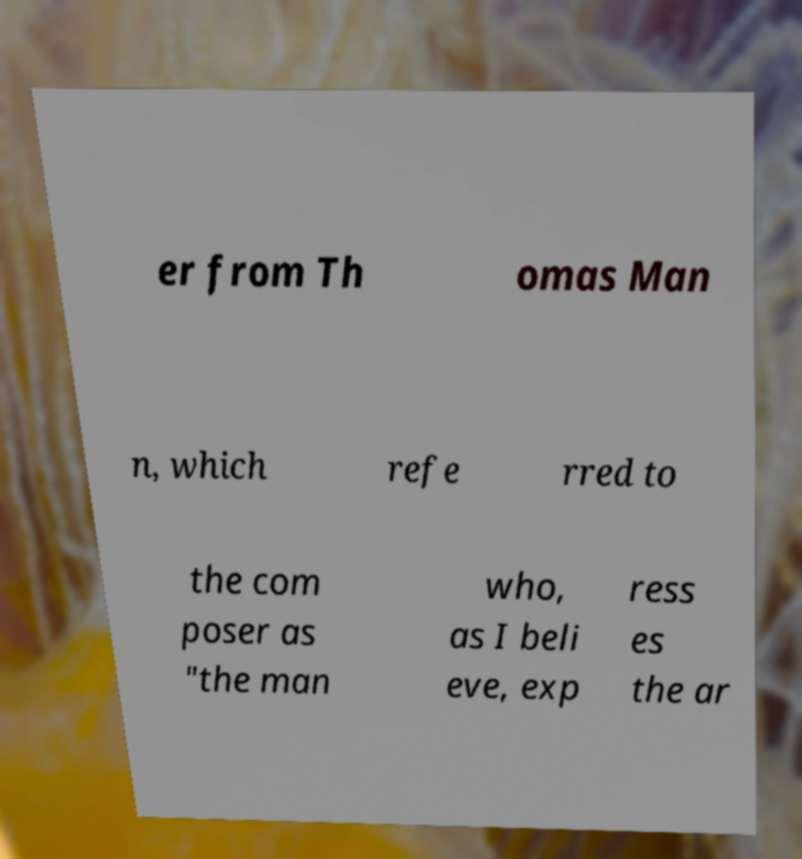There's text embedded in this image that I need extracted. Can you transcribe it verbatim? er from Th omas Man n, which refe rred to the com poser as "the man who, as I beli eve, exp ress es the ar 